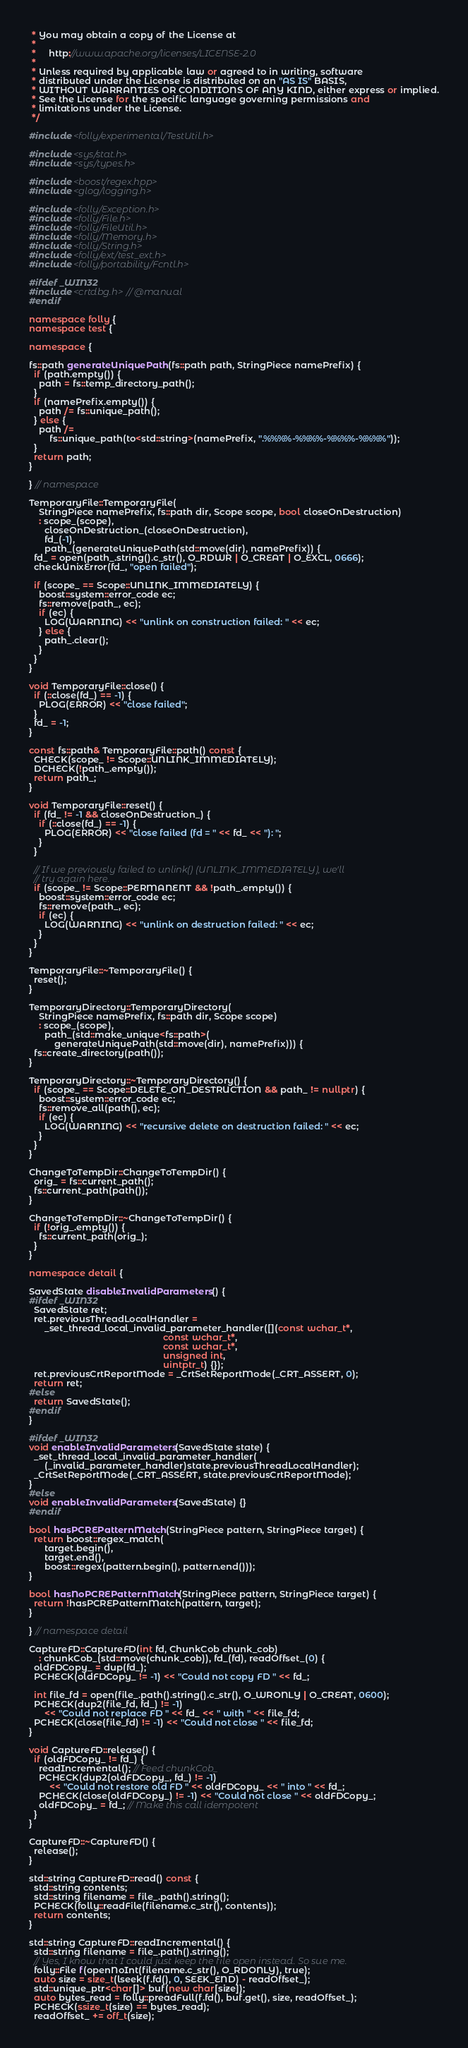Convert code to text. <code><loc_0><loc_0><loc_500><loc_500><_C++_> * You may obtain a copy of the License at
 *
 *     http://www.apache.org/licenses/LICENSE-2.0
 *
 * Unless required by applicable law or agreed to in writing, software
 * distributed under the License is distributed on an "AS IS" BASIS,
 * WITHOUT WARRANTIES OR CONDITIONS OF ANY KIND, either express or implied.
 * See the License for the specific language governing permissions and
 * limitations under the License.
 */

#include <folly/experimental/TestUtil.h>

#include <sys/stat.h>
#include <sys/types.h>

#include <boost/regex.hpp>
#include <glog/logging.h>

#include <folly/Exception.h>
#include <folly/File.h>
#include <folly/FileUtil.h>
#include <folly/Memory.h>
#include <folly/String.h>
#include <folly/ext/test_ext.h>
#include <folly/portability/Fcntl.h>

#ifdef _WIN32
#include <crtdbg.h> // @manual
#endif

namespace folly {
namespace test {

namespace {

fs::path generateUniquePath(fs::path path, StringPiece namePrefix) {
  if (path.empty()) {
    path = fs::temp_directory_path();
  }
  if (namePrefix.empty()) {
    path /= fs::unique_path();
  } else {
    path /=
        fs::unique_path(to<std::string>(namePrefix, ".%%%%-%%%%-%%%%-%%%%"));
  }
  return path;
}

} // namespace

TemporaryFile::TemporaryFile(
    StringPiece namePrefix, fs::path dir, Scope scope, bool closeOnDestruction)
    : scope_(scope),
      closeOnDestruction_(closeOnDestruction),
      fd_(-1),
      path_(generateUniquePath(std::move(dir), namePrefix)) {
  fd_ = open(path_.string().c_str(), O_RDWR | O_CREAT | O_EXCL, 0666);
  checkUnixError(fd_, "open failed");

  if (scope_ == Scope::UNLINK_IMMEDIATELY) {
    boost::system::error_code ec;
    fs::remove(path_, ec);
    if (ec) {
      LOG(WARNING) << "unlink on construction failed: " << ec;
    } else {
      path_.clear();
    }
  }
}

void TemporaryFile::close() {
  if (::close(fd_) == -1) {
    PLOG(ERROR) << "close failed";
  }
  fd_ = -1;
}

const fs::path& TemporaryFile::path() const {
  CHECK(scope_ != Scope::UNLINK_IMMEDIATELY);
  DCHECK(!path_.empty());
  return path_;
}

void TemporaryFile::reset() {
  if (fd_ != -1 && closeOnDestruction_) {
    if (::close(fd_) == -1) {
      PLOG(ERROR) << "close failed (fd = " << fd_ << "): ";
    }
  }

  // If we previously failed to unlink() (UNLINK_IMMEDIATELY), we'll
  // try again here.
  if (scope_ != Scope::PERMANENT && !path_.empty()) {
    boost::system::error_code ec;
    fs::remove(path_, ec);
    if (ec) {
      LOG(WARNING) << "unlink on destruction failed: " << ec;
    }
  }
}

TemporaryFile::~TemporaryFile() {
  reset();
}

TemporaryDirectory::TemporaryDirectory(
    StringPiece namePrefix, fs::path dir, Scope scope)
    : scope_(scope),
      path_(std::make_unique<fs::path>(
          generateUniquePath(std::move(dir), namePrefix))) {
  fs::create_directory(path());
}

TemporaryDirectory::~TemporaryDirectory() {
  if (scope_ == Scope::DELETE_ON_DESTRUCTION && path_ != nullptr) {
    boost::system::error_code ec;
    fs::remove_all(path(), ec);
    if (ec) {
      LOG(WARNING) << "recursive delete on destruction failed: " << ec;
    }
  }
}

ChangeToTempDir::ChangeToTempDir() {
  orig_ = fs::current_path();
  fs::current_path(path());
}

ChangeToTempDir::~ChangeToTempDir() {
  if (!orig_.empty()) {
    fs::current_path(orig_);
  }
}

namespace detail {

SavedState disableInvalidParameters() {
#ifdef _WIN32
  SavedState ret;
  ret.previousThreadLocalHandler =
      _set_thread_local_invalid_parameter_handler([](const wchar_t*,
                                                     const wchar_t*,
                                                     const wchar_t*,
                                                     unsigned int,
                                                     uintptr_t) {});
  ret.previousCrtReportMode = _CrtSetReportMode(_CRT_ASSERT, 0);
  return ret;
#else
  return SavedState();
#endif
}

#ifdef _WIN32
void enableInvalidParameters(SavedState state) {
  _set_thread_local_invalid_parameter_handler(
      (_invalid_parameter_handler)state.previousThreadLocalHandler);
  _CrtSetReportMode(_CRT_ASSERT, state.previousCrtReportMode);
}
#else
void enableInvalidParameters(SavedState) {}
#endif

bool hasPCREPatternMatch(StringPiece pattern, StringPiece target) {
  return boost::regex_match(
      target.begin(),
      target.end(),
      boost::regex(pattern.begin(), pattern.end()));
}

bool hasNoPCREPatternMatch(StringPiece pattern, StringPiece target) {
  return !hasPCREPatternMatch(pattern, target);
}

} // namespace detail

CaptureFD::CaptureFD(int fd, ChunkCob chunk_cob)
    : chunkCob_(std::move(chunk_cob)), fd_(fd), readOffset_(0) {
  oldFDCopy_ = dup(fd_);
  PCHECK(oldFDCopy_ != -1) << "Could not copy FD " << fd_;

  int file_fd = open(file_.path().string().c_str(), O_WRONLY | O_CREAT, 0600);
  PCHECK(dup2(file_fd, fd_) != -1)
      << "Could not replace FD " << fd_ << " with " << file_fd;
  PCHECK(close(file_fd) != -1) << "Could not close " << file_fd;
}

void CaptureFD::release() {
  if (oldFDCopy_ != fd_) {
    readIncremental(); // Feed chunkCob_
    PCHECK(dup2(oldFDCopy_, fd_) != -1)
        << "Could not restore old FD " << oldFDCopy_ << " into " << fd_;
    PCHECK(close(oldFDCopy_) != -1) << "Could not close " << oldFDCopy_;
    oldFDCopy_ = fd_; // Make this call idempotent
  }
}

CaptureFD::~CaptureFD() {
  release();
}

std::string CaptureFD::read() const {
  std::string contents;
  std::string filename = file_.path().string();
  PCHECK(folly::readFile(filename.c_str(), contents));
  return contents;
}

std::string CaptureFD::readIncremental() {
  std::string filename = file_.path().string();
  // Yes, I know that I could just keep the file open instead. So sue me.
  folly::File f(openNoInt(filename.c_str(), O_RDONLY), true);
  auto size = size_t(lseek(f.fd(), 0, SEEK_END) - readOffset_);
  std::unique_ptr<char[]> buf(new char[size]);
  auto bytes_read = folly::preadFull(f.fd(), buf.get(), size, readOffset_);
  PCHECK(ssize_t(size) == bytes_read);
  readOffset_ += off_t(size);</code> 